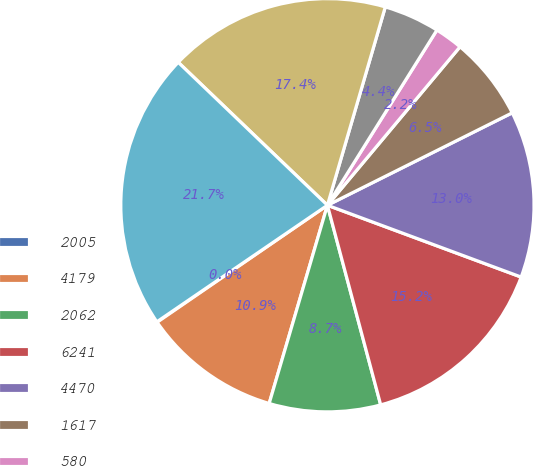Convert chart to OTSL. <chart><loc_0><loc_0><loc_500><loc_500><pie_chart><fcel>2005<fcel>4179<fcel>2062<fcel>6241<fcel>4470<fcel>1617<fcel>580<fcel>1037<fcel>1900<fcel>26947<nl><fcel>0.04%<fcel>10.87%<fcel>8.7%<fcel>15.2%<fcel>13.03%<fcel>6.53%<fcel>2.2%<fcel>4.37%<fcel>17.36%<fcel>21.7%<nl></chart> 